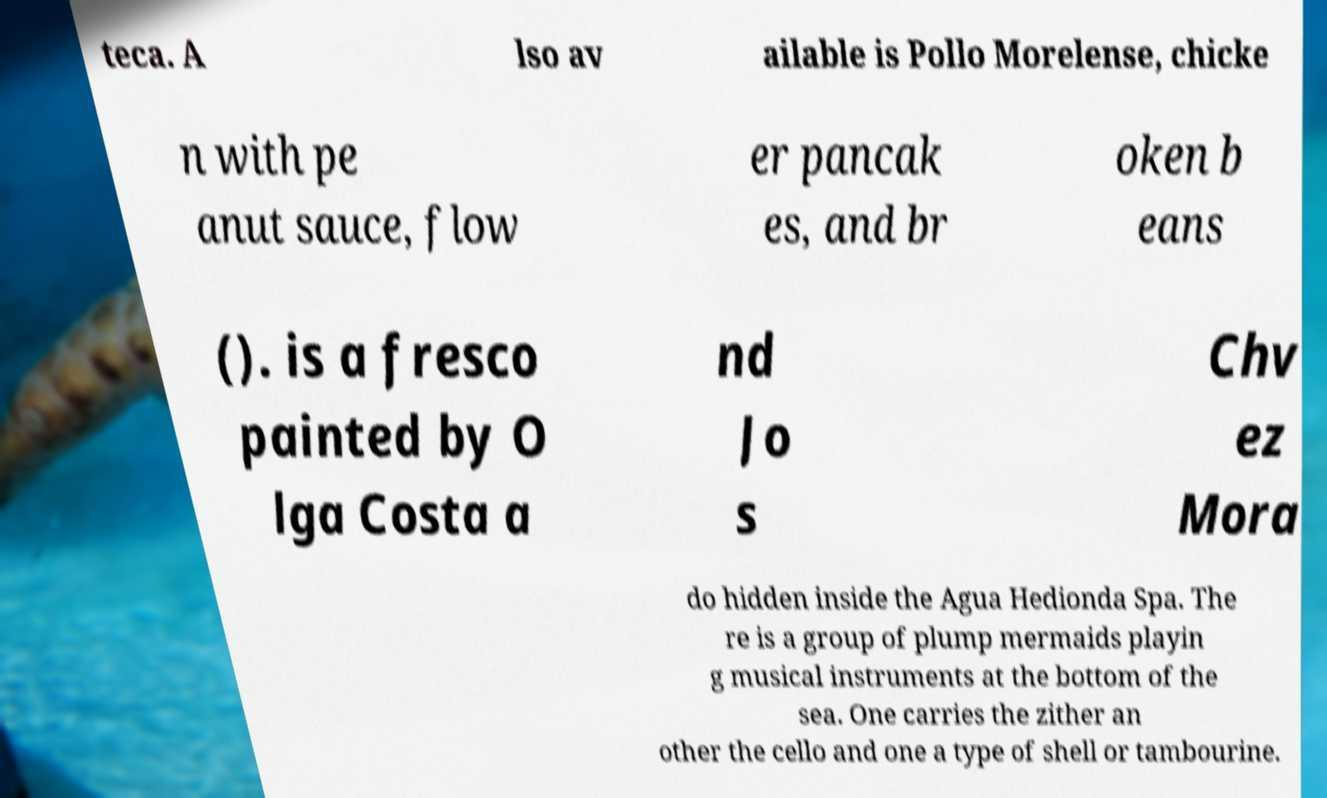There's text embedded in this image that I need extracted. Can you transcribe it verbatim? teca. A lso av ailable is Pollo Morelense, chicke n with pe anut sauce, flow er pancak es, and br oken b eans (). is a fresco painted by O lga Costa a nd Jo s Chv ez Mora do hidden inside the Agua Hedionda Spa. The re is a group of plump mermaids playin g musical instruments at the bottom of the sea. One carries the zither an other the cello and one a type of shell or tambourine. 